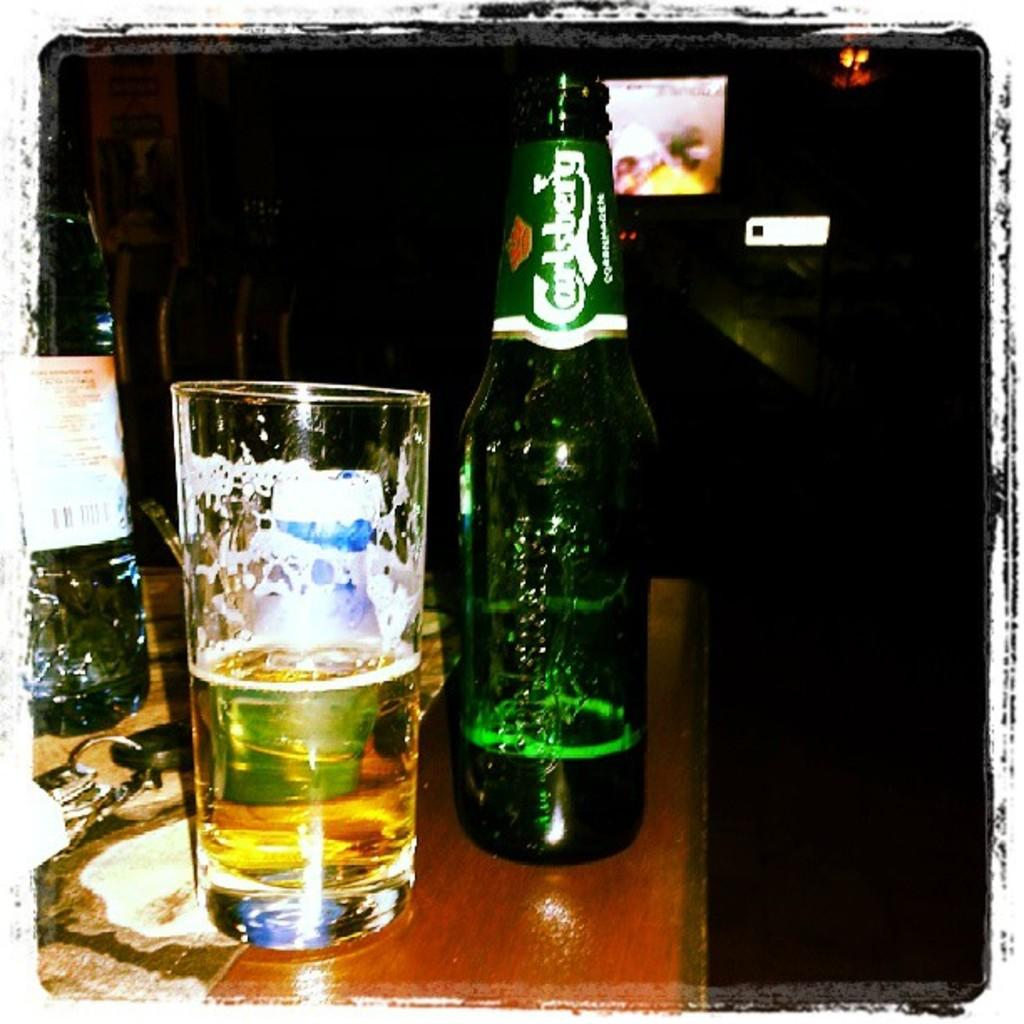<image>
Relay a brief, clear account of the picture shown. A mostly empty bottle of Carlsberg beer next to a half empty glass of beer. 